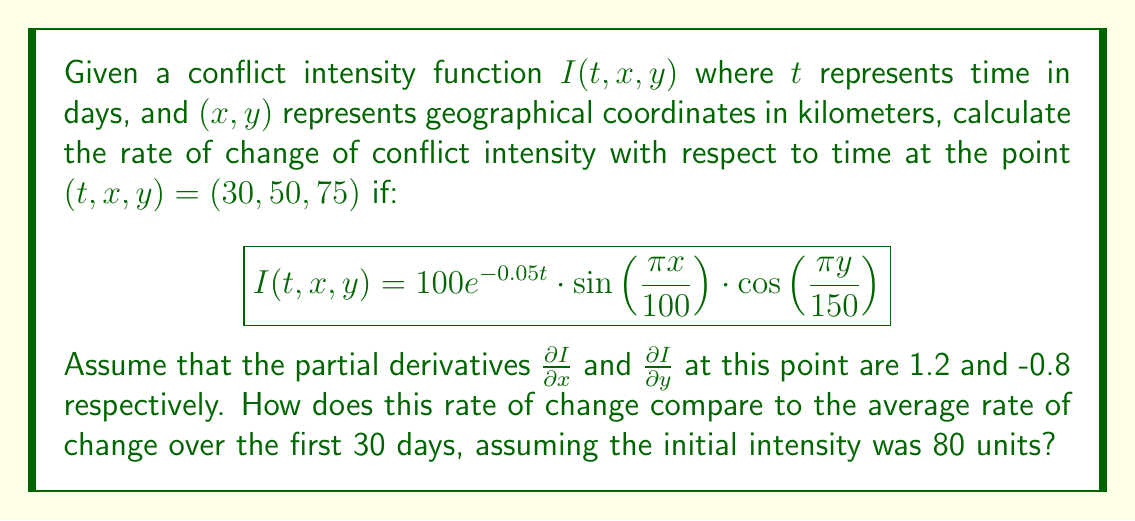Give your solution to this math problem. To solve this problem, we need to follow these steps:

1) First, we calculate the partial derivative of $I$ with respect to $t$:

   $$\frac{\partial I}{\partial t} = -5e^{-0.05t} \cdot \sin\left(\frac{\pi x}{100}\right) \cdot \cos\left(\frac{\pi y}{150}\right)$$

2) Now, we evaluate this at the point (30, 50, 75):

   $$\frac{\partial I}{\partial t}\bigg|_{(30,50,75)} = -5e^{-1.5} \cdot \sin\left(\frac{\pi \cdot 50}{100}\right) \cdot \cos\left(\frac{\pi \cdot 75}{150}\right)$$
   
   $$= -5e^{-1.5} \cdot 1 \cdot 0 = 0$$

3) The rate of change of conflict intensity with respect to time at this point is 0.

4) To compare this with the average rate of change over the first 30 days:

   Initial intensity: $I(0, 50, 75) = 100 \cdot \sin\left(\frac{\pi \cdot 50}{100}\right) \cdot \cos\left(\frac{\pi \cdot 75}{150}\right) = 100 \cdot 1 \cdot 0 = 0$

   The average rate of change is:

   $$\frac{I(30, 50, 75) - I(0, 50, 75)}{30} = \frac{0 - 80}{30} = -\frac{8}{3} \approx -2.67$$

5) The instantaneous rate of change (0) is significantly different from the average rate of change (-2.67), indicating a potential stabilization of the conflict at this specific point and time, despite an overall decreasing trend in intensity.
Answer: Instantaneous rate: 0; Average rate: $-\frac{8}{3}$ 